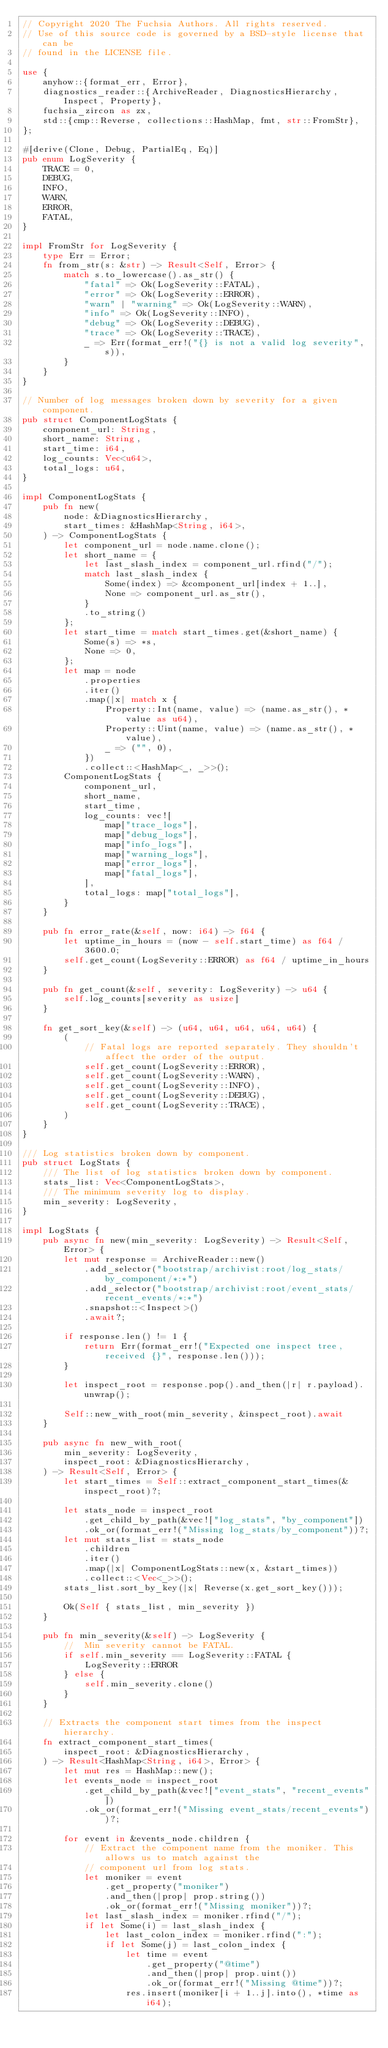Convert code to text. <code><loc_0><loc_0><loc_500><loc_500><_Rust_>// Copyright 2020 The Fuchsia Authors. All rights reserved.
// Use of this source code is governed by a BSD-style license that can be
// found in the LICENSE file.

use {
    anyhow::{format_err, Error},
    diagnostics_reader::{ArchiveReader, DiagnosticsHierarchy, Inspect, Property},
    fuchsia_zircon as zx,
    std::{cmp::Reverse, collections::HashMap, fmt, str::FromStr},
};

#[derive(Clone, Debug, PartialEq, Eq)]
pub enum LogSeverity {
    TRACE = 0,
    DEBUG,
    INFO,
    WARN,
    ERROR,
    FATAL,
}

impl FromStr for LogSeverity {
    type Err = Error;
    fn from_str(s: &str) -> Result<Self, Error> {
        match s.to_lowercase().as_str() {
            "fatal" => Ok(LogSeverity::FATAL),
            "error" => Ok(LogSeverity::ERROR),
            "warn" | "warning" => Ok(LogSeverity::WARN),
            "info" => Ok(LogSeverity::INFO),
            "debug" => Ok(LogSeverity::DEBUG),
            "trace" => Ok(LogSeverity::TRACE),
            _ => Err(format_err!("{} is not a valid log severity", s)),
        }
    }
}

// Number of log messages broken down by severity for a given component.
pub struct ComponentLogStats {
    component_url: String,
    short_name: String,
    start_time: i64,
    log_counts: Vec<u64>,
    total_logs: u64,
}

impl ComponentLogStats {
    pub fn new(
        node: &DiagnosticsHierarchy,
        start_times: &HashMap<String, i64>,
    ) -> ComponentLogStats {
        let component_url = node.name.clone();
        let short_name = {
            let last_slash_index = component_url.rfind("/");
            match last_slash_index {
                Some(index) => &component_url[index + 1..],
                None => component_url.as_str(),
            }
            .to_string()
        };
        let start_time = match start_times.get(&short_name) {
            Some(s) => *s,
            None => 0,
        };
        let map = node
            .properties
            .iter()
            .map(|x| match x {
                Property::Int(name, value) => (name.as_str(), *value as u64),
                Property::Uint(name, value) => (name.as_str(), *value),
                _ => ("", 0),
            })
            .collect::<HashMap<_, _>>();
        ComponentLogStats {
            component_url,
            short_name,
            start_time,
            log_counts: vec![
                map["trace_logs"],
                map["debug_logs"],
                map["info_logs"],
                map["warning_logs"],
                map["error_logs"],
                map["fatal_logs"],
            ],
            total_logs: map["total_logs"],
        }
    }

    pub fn error_rate(&self, now: i64) -> f64 {
        let uptime_in_hours = (now - self.start_time) as f64 / 3600.0;
        self.get_count(LogSeverity::ERROR) as f64 / uptime_in_hours
    }

    pub fn get_count(&self, severity: LogSeverity) -> u64 {
        self.log_counts[severity as usize]
    }

    fn get_sort_key(&self) -> (u64, u64, u64, u64, u64) {
        (
            // Fatal logs are reported separately. They shouldn't affect the order of the output.
            self.get_count(LogSeverity::ERROR),
            self.get_count(LogSeverity::WARN),
            self.get_count(LogSeverity::INFO),
            self.get_count(LogSeverity::DEBUG),
            self.get_count(LogSeverity::TRACE),
        )
    }
}

/// Log statistics broken down by component.
pub struct LogStats {
    /// The list of log statistics broken down by component.
    stats_list: Vec<ComponentLogStats>,
    /// The minimum severity log to display.
    min_severity: LogSeverity,
}

impl LogStats {
    pub async fn new(min_severity: LogSeverity) -> Result<Self, Error> {
        let mut response = ArchiveReader::new()
            .add_selector("bootstrap/archivist:root/log_stats/by_component/*:*")
            .add_selector("bootstrap/archivist:root/event_stats/recent_events/*:*")
            .snapshot::<Inspect>()
            .await?;

        if response.len() != 1 {
            return Err(format_err!("Expected one inspect tree, received {}", response.len()));
        }

        let inspect_root = response.pop().and_then(|r| r.payload).unwrap();

        Self::new_with_root(min_severity, &inspect_root).await
    }

    pub async fn new_with_root(
        min_severity: LogSeverity,
        inspect_root: &DiagnosticsHierarchy,
    ) -> Result<Self, Error> {
        let start_times = Self::extract_component_start_times(&inspect_root)?;

        let stats_node = inspect_root
            .get_child_by_path(&vec!["log_stats", "by_component"])
            .ok_or(format_err!("Missing log_stats/by_component"))?;
        let mut stats_list = stats_node
            .children
            .iter()
            .map(|x| ComponentLogStats::new(x, &start_times))
            .collect::<Vec<_>>();
        stats_list.sort_by_key(|x| Reverse(x.get_sort_key()));

        Ok(Self { stats_list, min_severity })
    }

    pub fn min_severity(&self) -> LogSeverity {
        //  Min severity cannot be FATAL.
        if self.min_severity == LogSeverity::FATAL {
            LogSeverity::ERROR
        } else {
            self.min_severity.clone()
        }
    }

    // Extracts the component start times from the inspect hierarchy.
    fn extract_component_start_times(
        inspect_root: &DiagnosticsHierarchy,
    ) -> Result<HashMap<String, i64>, Error> {
        let mut res = HashMap::new();
        let events_node = inspect_root
            .get_child_by_path(&vec!["event_stats", "recent_events"])
            .ok_or(format_err!("Missing event_stats/recent_events"))?;

        for event in &events_node.children {
            // Extract the component name from the moniker. This allows us to match against the
            // component url from log stats.
            let moniker = event
                .get_property("moniker")
                .and_then(|prop| prop.string())
                .ok_or(format_err!("Missing moniker"))?;
            let last_slash_index = moniker.rfind("/");
            if let Some(i) = last_slash_index {
                let last_colon_index = moniker.rfind(":");
                if let Some(j) = last_colon_index {
                    let time = event
                        .get_property("@time")
                        .and_then(|prop| prop.uint())
                        .ok_or(format_err!("Missing @time"))?;
                    res.insert(moniker[i + 1..j].into(), *time as i64);</code> 